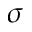<formula> <loc_0><loc_0><loc_500><loc_500>\sigma</formula> 